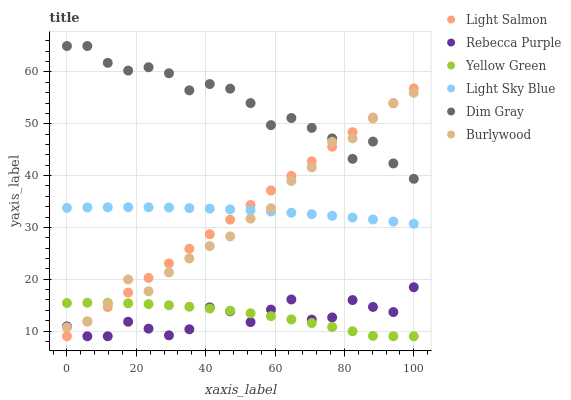Does Rebecca Purple have the minimum area under the curve?
Answer yes or no. Yes. Does Dim Gray have the maximum area under the curve?
Answer yes or no. Yes. Does Yellow Green have the minimum area under the curve?
Answer yes or no. No. Does Yellow Green have the maximum area under the curve?
Answer yes or no. No. Is Light Salmon the smoothest?
Answer yes or no. Yes. Is Rebecca Purple the roughest?
Answer yes or no. Yes. Is Dim Gray the smoothest?
Answer yes or no. No. Is Dim Gray the roughest?
Answer yes or no. No. Does Light Salmon have the lowest value?
Answer yes or no. Yes. Does Dim Gray have the lowest value?
Answer yes or no. No. Does Dim Gray have the highest value?
Answer yes or no. Yes. Does Yellow Green have the highest value?
Answer yes or no. No. Is Yellow Green less than Dim Gray?
Answer yes or no. Yes. Is Dim Gray greater than Yellow Green?
Answer yes or no. Yes. Does Yellow Green intersect Rebecca Purple?
Answer yes or no. Yes. Is Yellow Green less than Rebecca Purple?
Answer yes or no. No. Is Yellow Green greater than Rebecca Purple?
Answer yes or no. No. Does Yellow Green intersect Dim Gray?
Answer yes or no. No. 